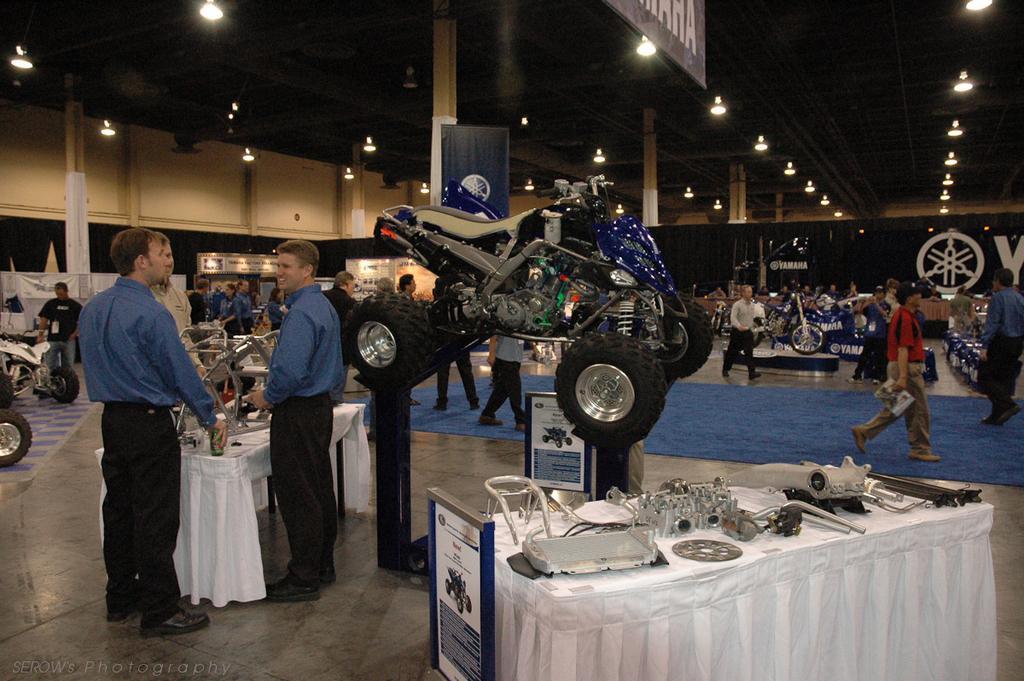How would you summarize this image in a sentence or two? In the middle of the picture we can see a vehicle and beside it, we can see two people are standing near the table and on the table, we can see some objects and in the background, we can see some people are walking and we can see some vehicles and to the ceiling we can see the lights. 